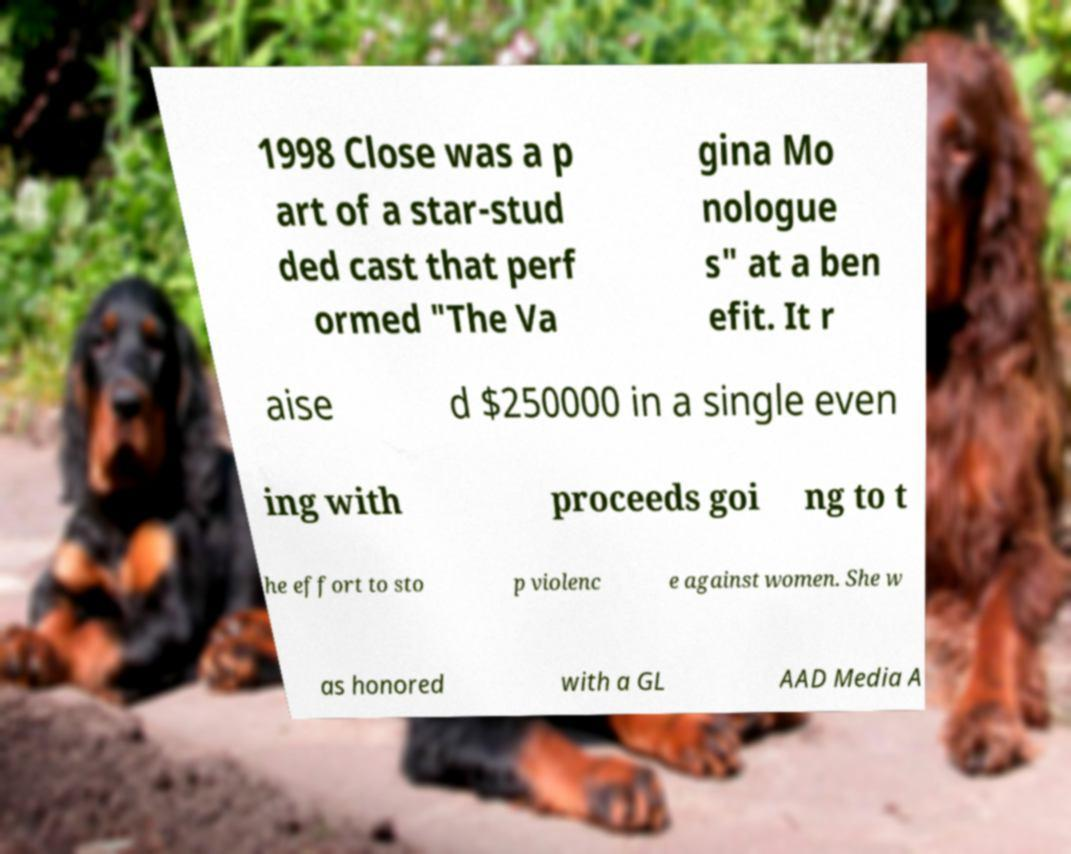Can you accurately transcribe the text from the provided image for me? 1998 Close was a p art of a star-stud ded cast that perf ormed "The Va gina Mo nologue s" at a ben efit. It r aise d $250000 in a single even ing with proceeds goi ng to t he effort to sto p violenc e against women. She w as honored with a GL AAD Media A 